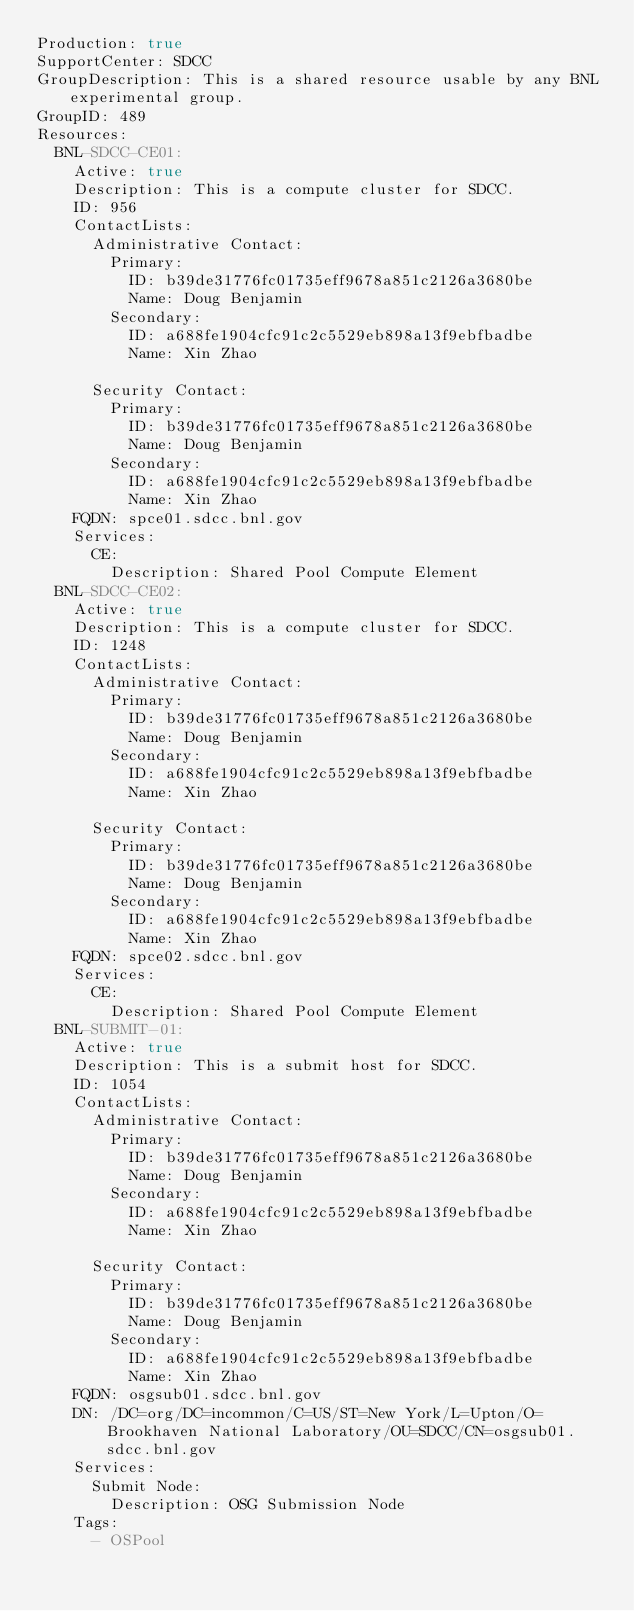<code> <loc_0><loc_0><loc_500><loc_500><_YAML_>Production: true
SupportCenter: SDCC
GroupDescription: This is a shared resource usable by any BNL experimental group.
GroupID: 489
Resources:
  BNL-SDCC-CE01:
    Active: true
    Description: This is a compute cluster for SDCC.
    ID: 956
    ContactLists:
      Administrative Contact:
        Primary:
          ID: b39de31776fc01735eff9678a851c2126a3680be
          Name: Doug Benjamin
        Secondary:
          ID: a688fe1904cfc91c2c5529eb898a13f9ebfbadbe
          Name: Xin Zhao

      Security Contact:
        Primary:
          ID: b39de31776fc01735eff9678a851c2126a3680be
          Name: Doug Benjamin
        Secondary:
          ID: a688fe1904cfc91c2c5529eb898a13f9ebfbadbe
          Name: Xin Zhao
    FQDN: spce01.sdcc.bnl.gov
    Services:
      CE:
        Description: Shared Pool Compute Element
  BNL-SDCC-CE02:
    Active: true
    Description: This is a compute cluster for SDCC.
    ID: 1248
    ContactLists:
      Administrative Contact:
        Primary:
          ID: b39de31776fc01735eff9678a851c2126a3680be
          Name: Doug Benjamin
        Secondary:
          ID: a688fe1904cfc91c2c5529eb898a13f9ebfbadbe
          Name: Xin Zhao

      Security Contact:
        Primary:
          ID: b39de31776fc01735eff9678a851c2126a3680be
          Name: Doug Benjamin
        Secondary:
          ID: a688fe1904cfc91c2c5529eb898a13f9ebfbadbe
          Name: Xin Zhao
    FQDN: spce02.sdcc.bnl.gov
    Services:
      CE:
        Description: Shared Pool Compute Element
  BNL-SUBMIT-01:
    Active: true
    Description: This is a submit host for SDCC.
    ID: 1054
    ContactLists:
      Administrative Contact:
        Primary:
          ID: b39de31776fc01735eff9678a851c2126a3680be
          Name: Doug Benjamin
        Secondary:
          ID: a688fe1904cfc91c2c5529eb898a13f9ebfbadbe
          Name: Xin Zhao

      Security Contact:
        Primary:
          ID: b39de31776fc01735eff9678a851c2126a3680be
          Name: Doug Benjamin
        Secondary:
          ID: a688fe1904cfc91c2c5529eb898a13f9ebfbadbe
          Name: Xin Zhao
    FQDN: osgsub01.sdcc.bnl.gov
    DN: /DC=org/DC=incommon/C=US/ST=New York/L=Upton/O=Brookhaven National Laboratory/OU=SDCC/CN=osgsub01.sdcc.bnl.gov
    Services:
      Submit Node:
        Description: OSG Submission Node
    Tags:
      - OSPool
</code> 